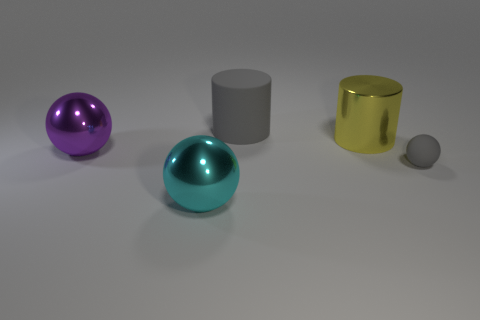Subtract all purple cylinders. Subtract all brown spheres. How many cylinders are left? 2 Add 4 small things. How many objects exist? 9 Subtract all cylinders. How many objects are left? 3 Subtract all small red shiny spheres. Subtract all tiny matte things. How many objects are left? 4 Add 2 large metallic balls. How many large metallic balls are left? 4 Add 5 big gray matte cylinders. How many big gray matte cylinders exist? 6 Subtract 0 red balls. How many objects are left? 5 